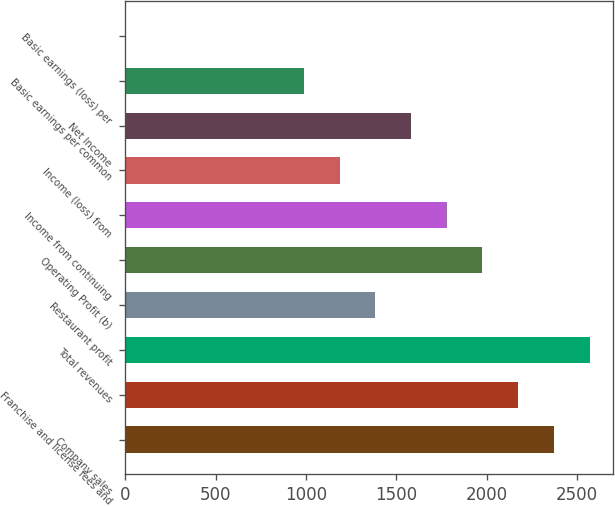Convert chart to OTSL. <chart><loc_0><loc_0><loc_500><loc_500><bar_chart><fcel>Company sales<fcel>Franchise and license fees and<fcel>Total revenues<fcel>Restaurant profit<fcel>Operating Profit (b)<fcel>Income from continuing<fcel>Income (loss) from<fcel>Net Income<fcel>Basic earnings per common<fcel>Basic earnings (loss) per<nl><fcel>2371.23<fcel>2173.63<fcel>2568.83<fcel>1383.23<fcel>1976.03<fcel>1778.43<fcel>1185.63<fcel>1580.83<fcel>988.03<fcel>0.03<nl></chart> 